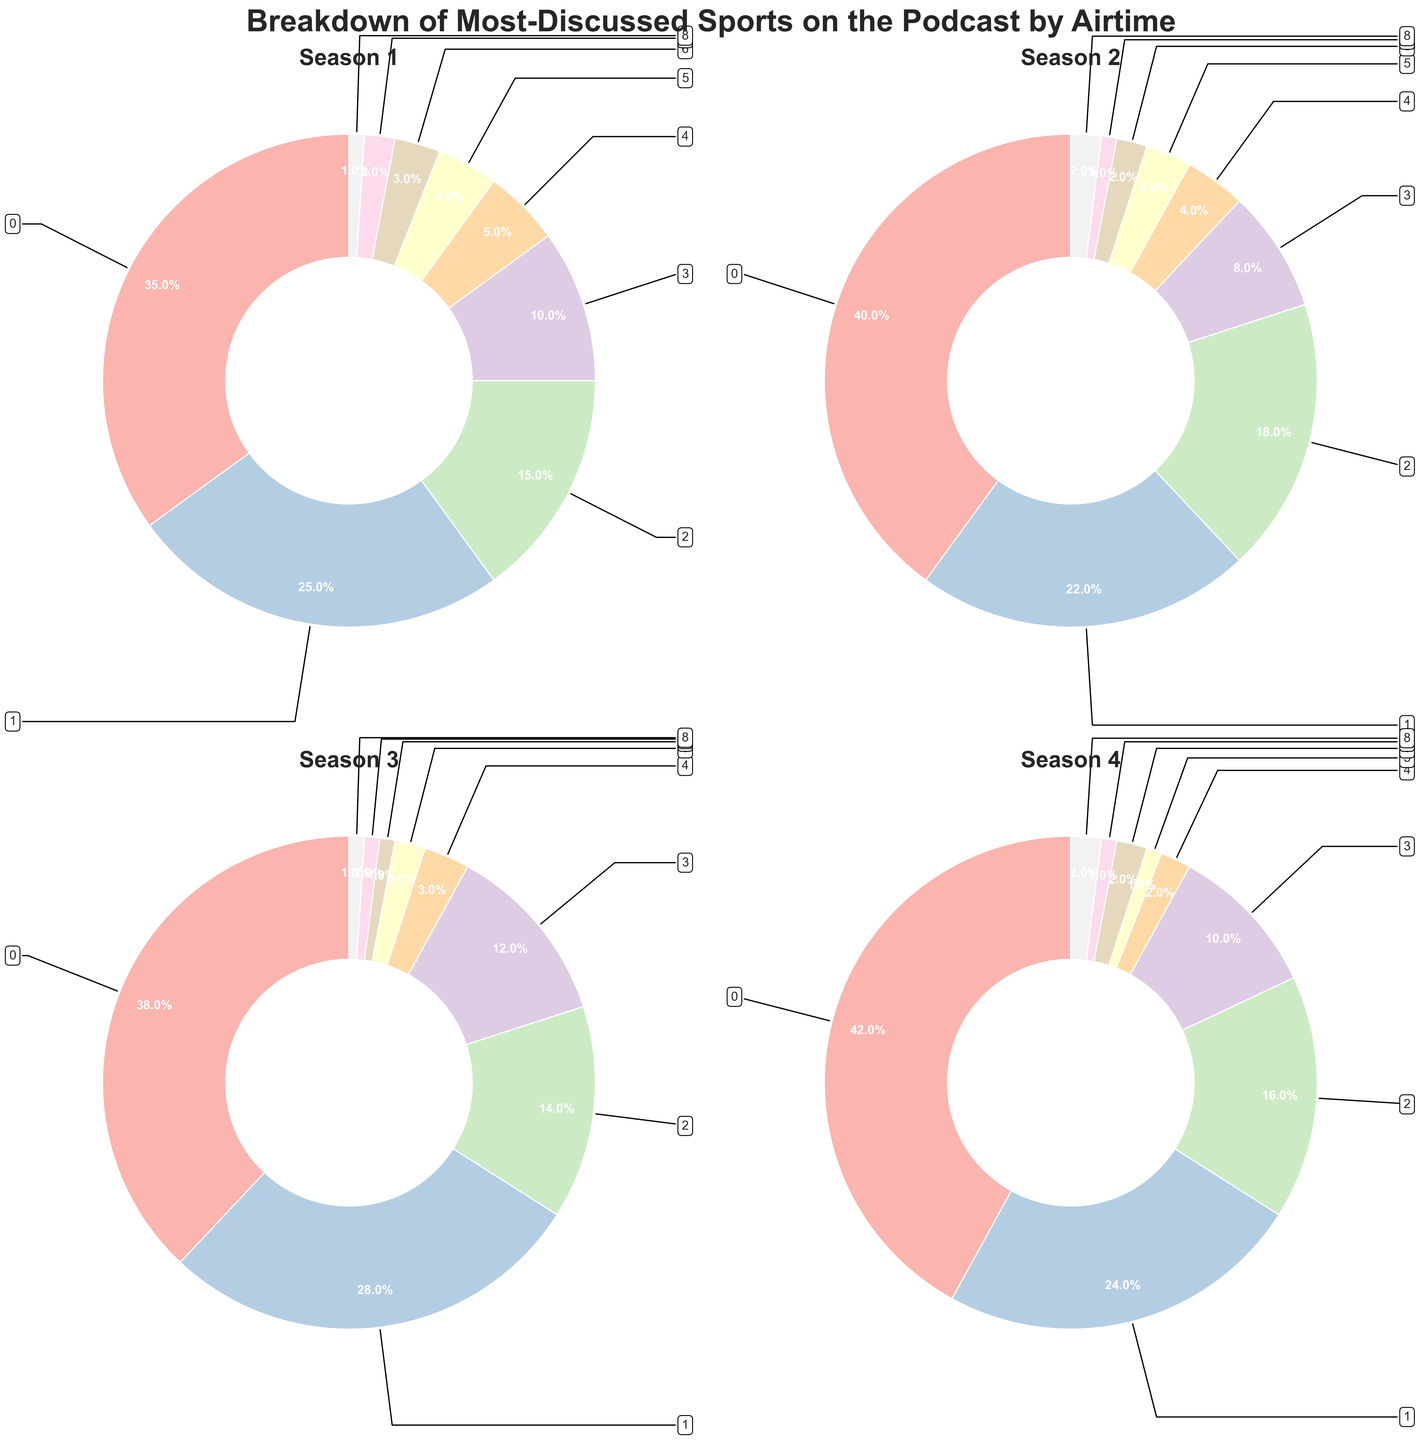Which sport had the highest airtime in Season 1? By looking at the pie chart for Season 1, the largest segment is for Football. This sport had the highest airtime.
Answer: Football Which sports maintained a consistent airtime of 10% or more across all four seasons? By observing the pie charts, only Football and Basketball consistently maintain 10% or more across all the seasons. Other sports fluctuate below 10% in some seasons.
Answer: Football and Basketball Comparing Season 1 and Season 4, which sport saw the greatest increase in airtime? To find this, compare the segments for each sport in both seasons. Football increased from 35% in Season 1 to 42% in Season 4, the largest increase observed.
Answer: Football How did the airtime percentage for Baseball change over the four seasons? Reviewing the pie charts for Baseball across seasons, it shows 15% in Season 1, 18% in Season 2, 14% in Season 3, and 16% in Season 4. It fluctuated over time, increasing in Season 2, then decreasing, and slightly increasing again.
Answer: Fluctuated What is the combined airtime percentage for Tennis, Golf, Hockey, Boxing, and MMA in Season 3? By adding the percentages of each sport for Season 3, Tennis (3%) + Golf (2%) + Hockey (1%) + Boxing (1%) + MMA (1%) = 8%.
Answer: 8% In which season did Soccer see the highest relative airtime percentage? Examining all seasons, Soccer had the highest relative airtime in Season 3 at 12%.
Answer: Season 3 Between Season 2 and Season 3, which sport had the largest drop in airtime? By comparing the pie charts, Basketball decreased from 22% in Season 2 to 28% in Season 3, a 6% drop, which is the largest.
Answer: Basketball In Season 4, did any sport have an airtime equal to or less than 2%? Observing the pie chart for Season 4, Tennis (2%), Golf (1%), Hockey (2%), and Boxing (1%) all had airtime of 2% or less.
Answer: Yes 